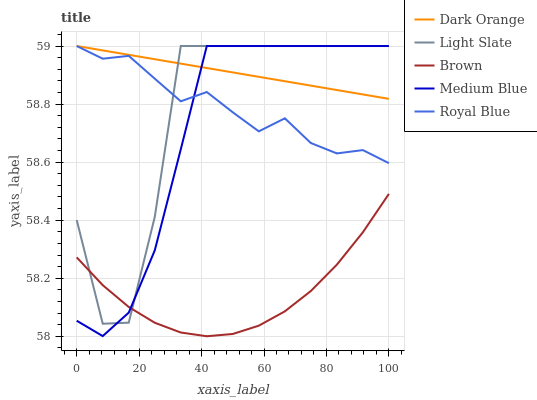Does Brown have the minimum area under the curve?
Answer yes or no. Yes. Does Dark Orange have the maximum area under the curve?
Answer yes or no. Yes. Does Medium Blue have the minimum area under the curve?
Answer yes or no. No. Does Medium Blue have the maximum area under the curve?
Answer yes or no. No. Is Dark Orange the smoothest?
Answer yes or no. Yes. Is Light Slate the roughest?
Answer yes or no. Yes. Is Medium Blue the smoothest?
Answer yes or no. No. Is Medium Blue the roughest?
Answer yes or no. No. Does Brown have the lowest value?
Answer yes or no. Yes. Does Medium Blue have the lowest value?
Answer yes or no. No. Does Royal Blue have the highest value?
Answer yes or no. Yes. Does Brown have the highest value?
Answer yes or no. No. Is Brown less than Dark Orange?
Answer yes or no. Yes. Is Dark Orange greater than Brown?
Answer yes or no. Yes. Does Medium Blue intersect Dark Orange?
Answer yes or no. Yes. Is Medium Blue less than Dark Orange?
Answer yes or no. No. Is Medium Blue greater than Dark Orange?
Answer yes or no. No. Does Brown intersect Dark Orange?
Answer yes or no. No. 